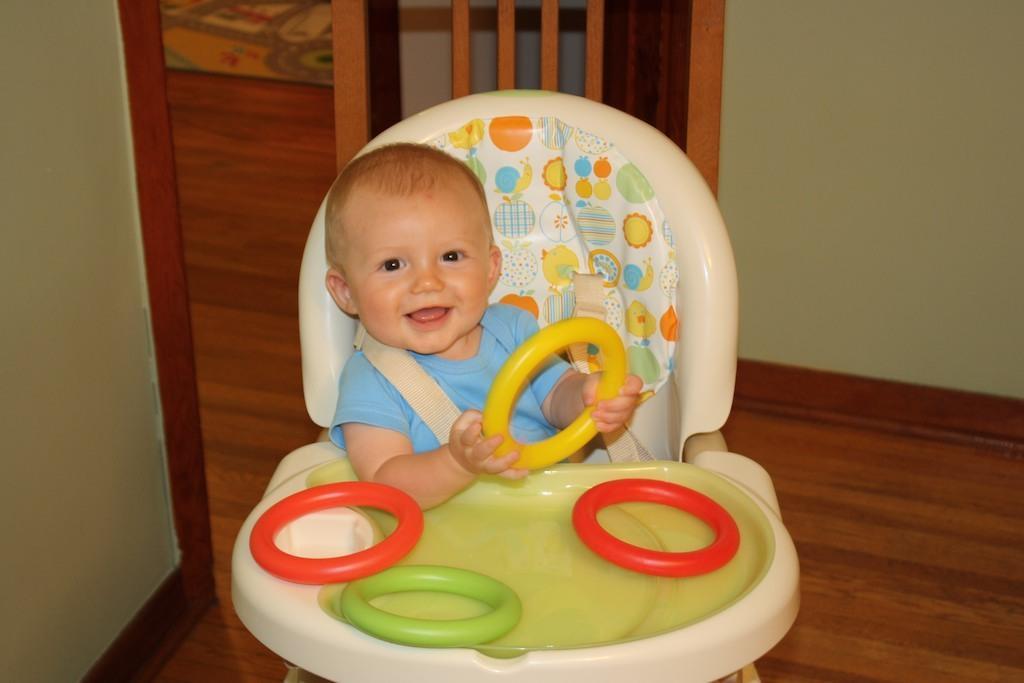Could you give a brief overview of what you see in this image? In this picture, we see the baby is in the baby walker. The baby is smiling and is holding a yellow color ring in the hands. We see the red, orange and green color rings are placed on the walker. At the bottom, we see the wooden floor. On the left side, we see a green color wall. Beside that, it looks like a bed. In the background, we see a wall. 